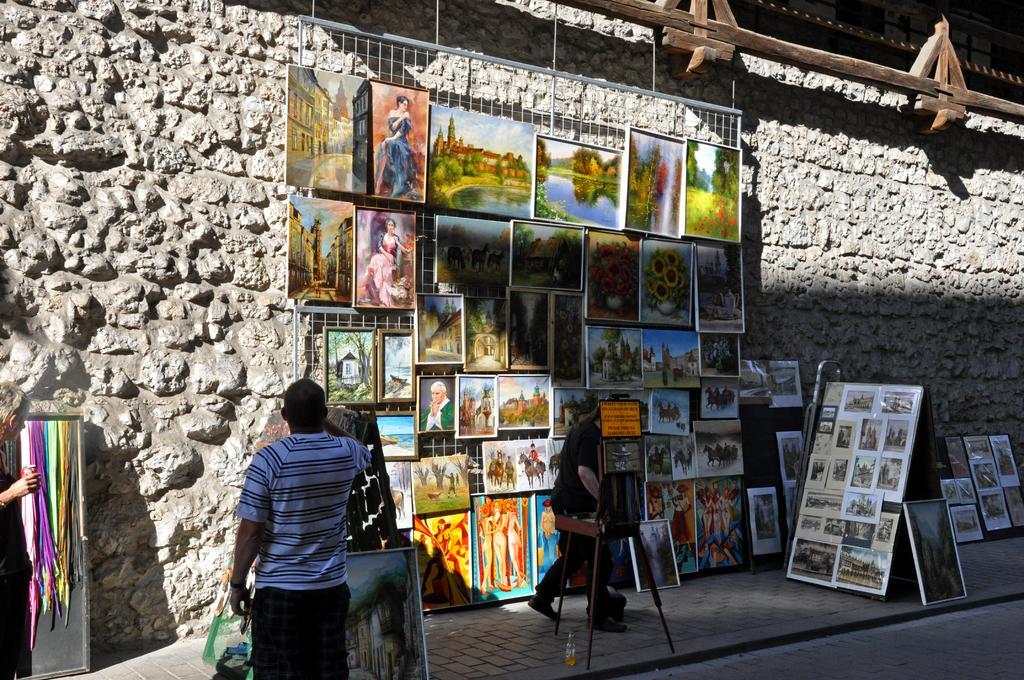How would you summarize this image in a sentence or two? In this image we can see the paintings and also photo frames. We can also see some threads on the left to the board. Image also consists of the stone wall, wooden rods and also three people. We can also see the bottle on the path. Road is also visible in this image. 